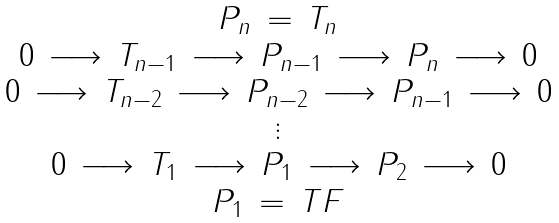Convert formula to latex. <formula><loc_0><loc_0><loc_500><loc_500>\begin{array} { c } P _ { n } \, = \, T _ { n } \\ 0 \, \longrightarrow \, T _ { n - 1 } \, \longrightarrow \, P _ { n - 1 } \, \longrightarrow \, P _ { n } \, \longrightarrow \, 0 \\ 0 \, \longrightarrow \, T _ { n - 2 } \, \longrightarrow \, P _ { n - 2 } \, \longrightarrow \, P _ { n - 1 } \, \longrightarrow \, 0 \\ \vdots \\ 0 \, \longrightarrow \, T _ { 1 } \, \longrightarrow \, P _ { 1 } \, \longrightarrow \, P _ { 2 } \, \longrightarrow \, 0 \\ P _ { 1 } \, = \, T F \end{array}</formula> 